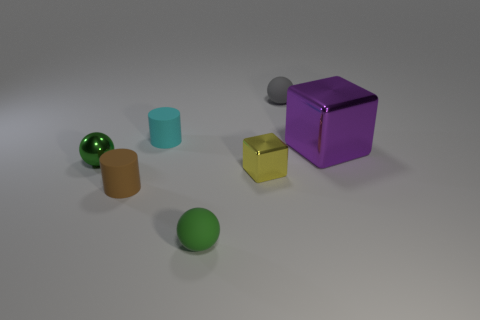How many objects are both to the right of the cyan matte cylinder and in front of the tiny cyan cylinder?
Make the answer very short. 3. Do the ball right of the small green matte ball and the cube on the right side of the gray object have the same color?
Provide a succinct answer. No. Are there any other things that are made of the same material as the gray sphere?
Your answer should be very brief. Yes. There is a purple object that is the same shape as the small yellow metal object; what size is it?
Ensure brevity in your answer.  Large. Are there any small green balls behind the brown cylinder?
Your answer should be very brief. Yes. Are there an equal number of big cubes that are to the right of the purple metal object and large blue metallic things?
Offer a terse response. Yes. There is a yellow thing to the left of the purple metal object in front of the cyan matte cylinder; are there any rubber cylinders on the right side of it?
Offer a terse response. No. What material is the tiny yellow block?
Provide a short and direct response. Metal. What number of other things are there of the same shape as the gray rubber thing?
Provide a short and direct response. 2. Does the tiny yellow object have the same shape as the cyan thing?
Offer a terse response. No. 